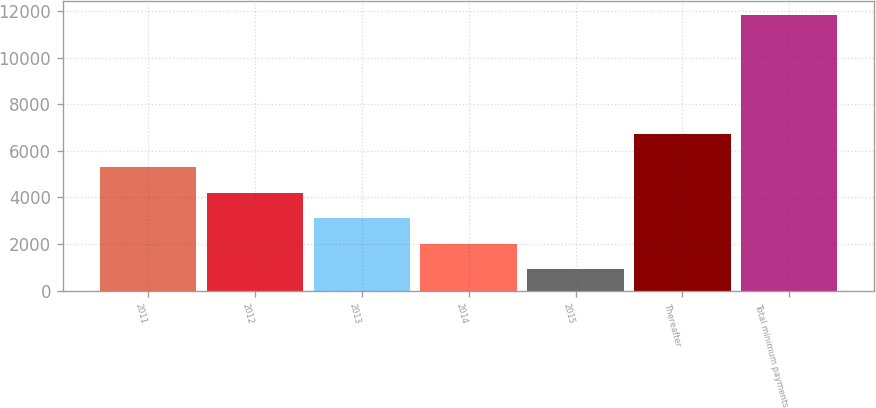Convert chart. <chart><loc_0><loc_0><loc_500><loc_500><bar_chart><fcel>2011<fcel>2012<fcel>2013<fcel>2014<fcel>2015<fcel>Thereafter<fcel>Total minimum payments<nl><fcel>5294.38<fcel>4202.31<fcel>3110.24<fcel>2018.17<fcel>926.1<fcel>6715.1<fcel>11846.8<nl></chart> 